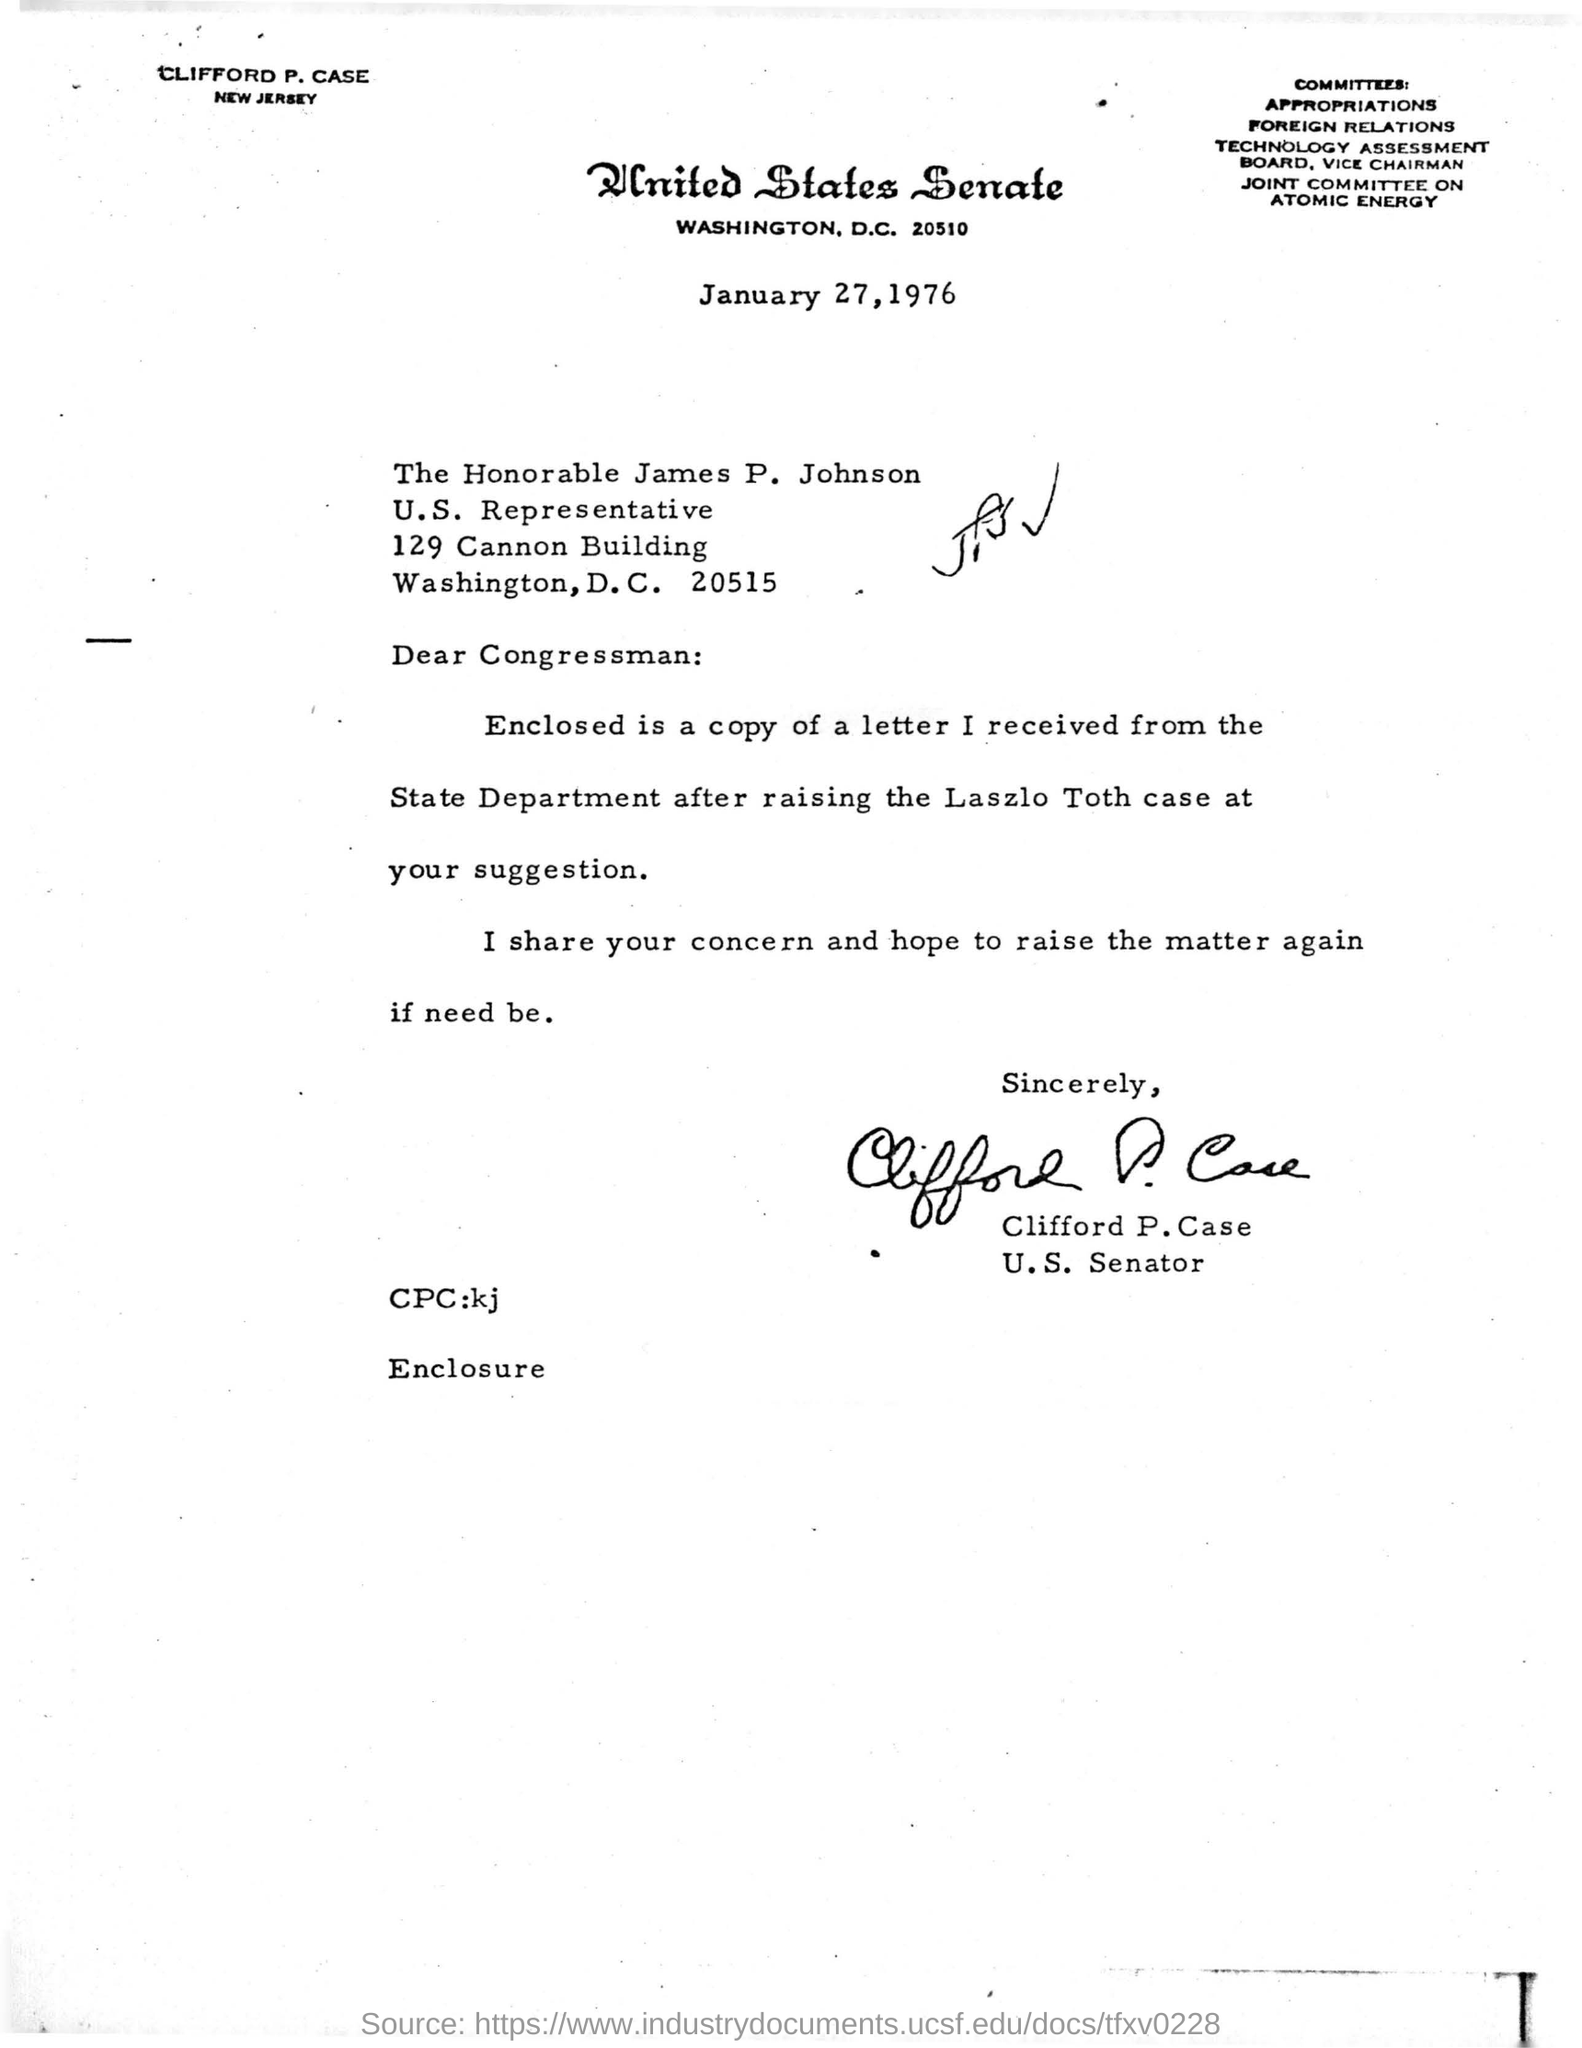Who has signed  the letter ?
Give a very brief answer. Clifford p.case. Who is james p.johnson ?
Your response must be concise. Congressman. On which date this letter was written ?
Make the answer very short. January 27,1976. Where is the united states senate located ?
Keep it short and to the point. Washington, d.c. 